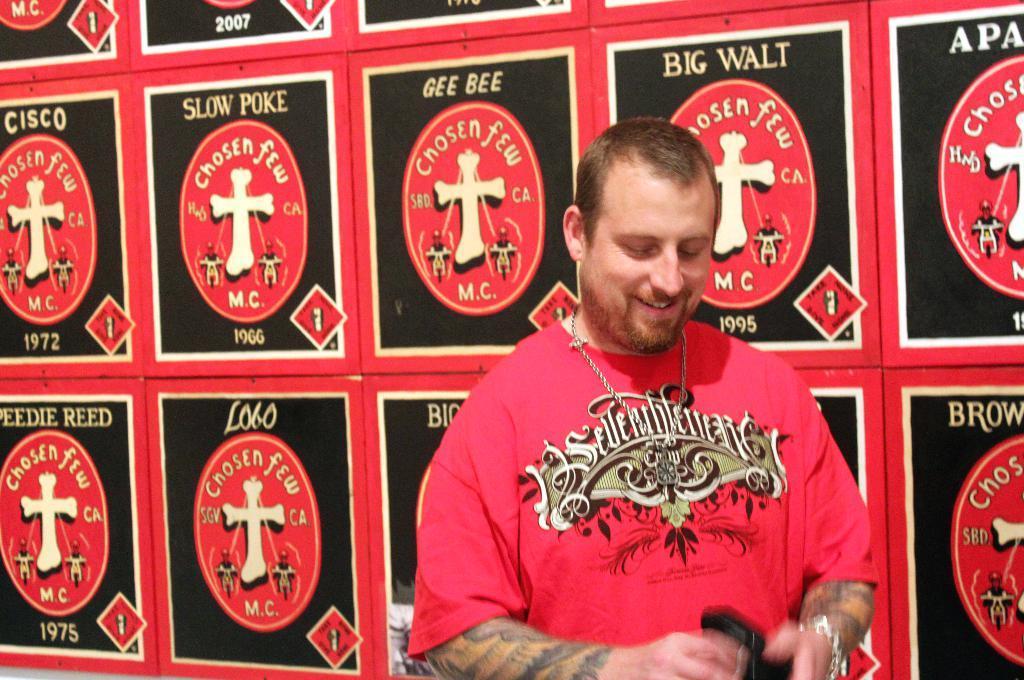Please provide a concise description of this image. In this image we can see a person. In the background of the image there are some posters. 